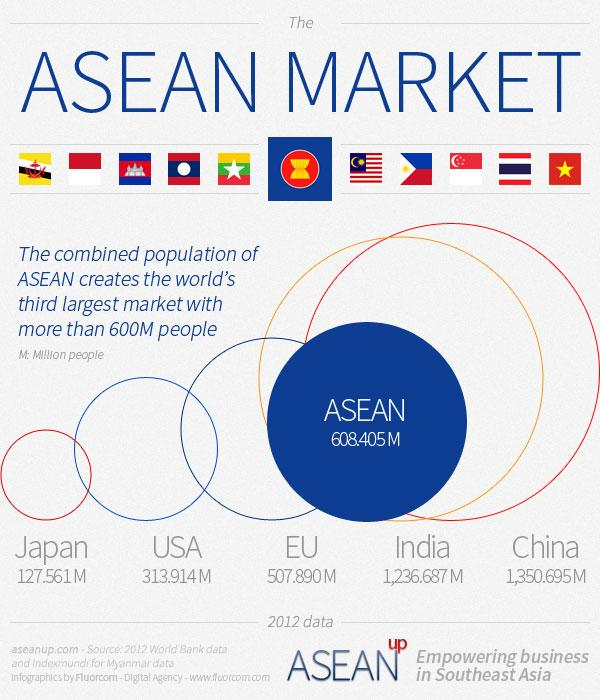List a handful of essential elements in this visual. This infographic contains 5 country names. There are 11 flags of different countries featured in this infographic. 